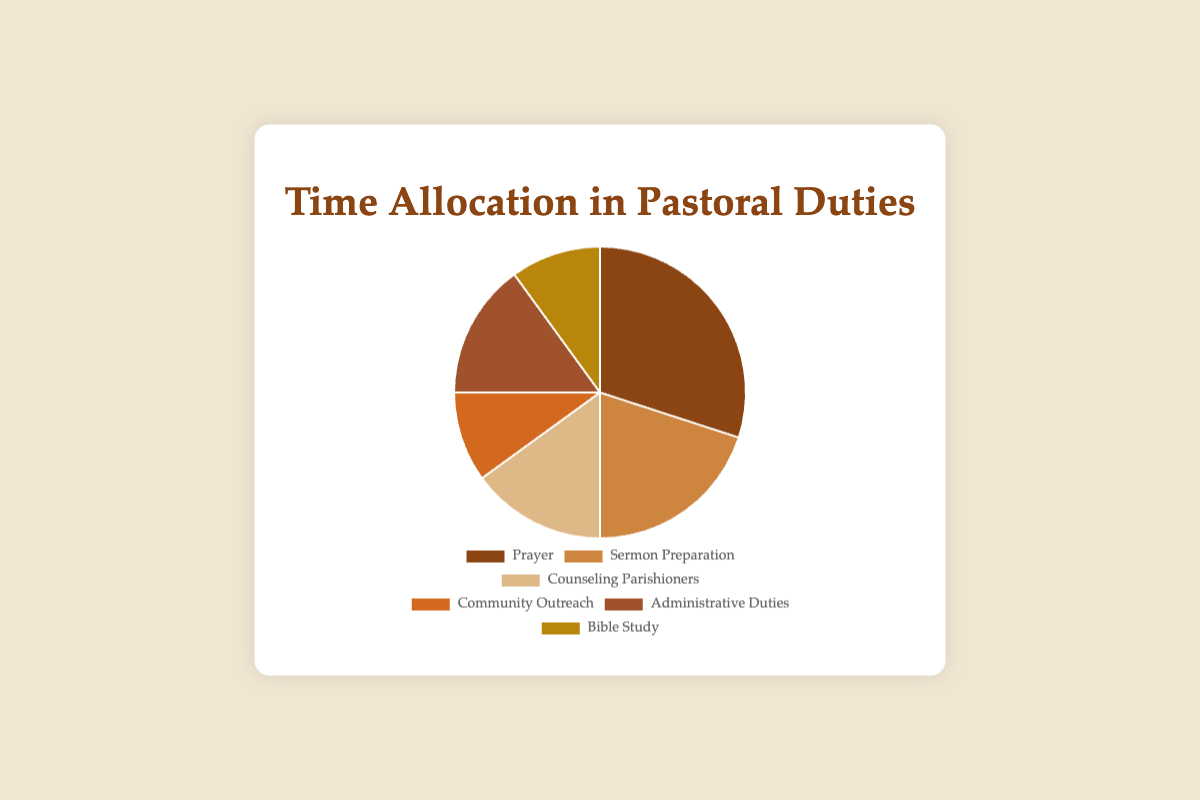What's the total percentage of time spent on Sermon Preparation, Counseling Parishioners, and Bible Study? Add the percentages for Sermon Preparation (20%), Counseling Parishioners (15%), and Bible Study (10%). 20 + 15 + 10 = 45.
Answer: 45% Which activity takes up more time: Prayer or Administrative Duties? Compare the percentages for Prayer (30%) and Administrative Duties (15%). Since 30% > 15%, Prayer occupies more time.
Answer: Prayer What is the difference in time allocation between Community Outreach and Bible Study? Subtract the percentage of time spent on Bible Study (10%) from Community Outreach (10%). 10 - 10 = 0.
Answer: 0 Which activity is allocated the least amount of time on the pie chart? Identify the activity with the smallest percentage. Community Outreach and Bible Study both have the smallest percentage at 10%.
Answer: Community Outreach, Bible Study What is the combined time percentage of Prayer and Administrative Duties? Add the percentages for Prayer (30%) and Administrative Duties (15%). 30 + 15 = 45.
Answer: 45% Is more time spent on Counseling Parishioners than on Community Outreach? Compare the percentages for Counseling Parishioners (15%) and Community Outreach (10%). Since 15% > 10%, more time is spent on Counseling Parishioners.
Answer: Yes What is the average percentage of time spent on all activities? Sum the percentages and divide by the number of activities. (30 + 20 + 15 + 10 + 15 + 10) / 6 = 100 / 6 ≈ 16.67.
Answer: 16.67% Which two activities collectively take up 30% of the time? Identify the activities whose combined percentages equal 30. Community Outreach (10%) and Bible Study (10%) together equal 30%.
Answer: Community Outreach, Bible Study 